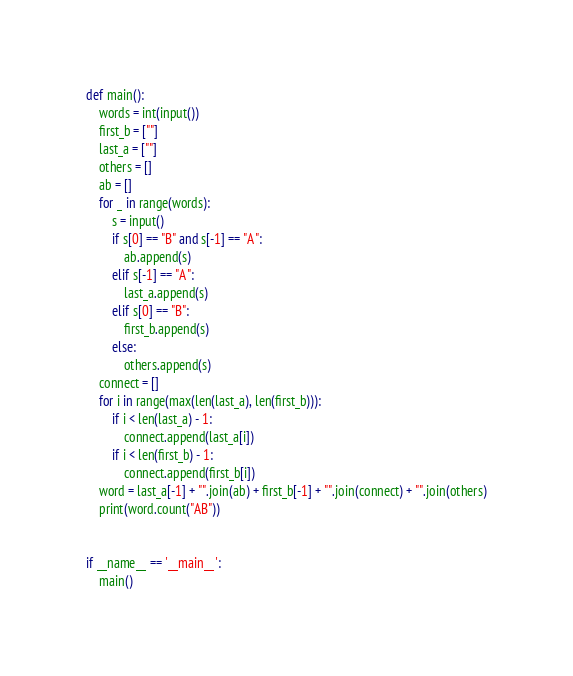<code> <loc_0><loc_0><loc_500><loc_500><_Python_>def main():
    words = int(input())
    first_b = [""]
    last_a = [""]
    others = []
    ab = []
    for _ in range(words):
        s = input()
        if s[0] == "B" and s[-1] == "A":
            ab.append(s)
        elif s[-1] == "A":
            last_a.append(s)
        elif s[0] == "B":
            first_b.append(s)
        else:
            others.append(s)
    connect = []
    for i in range(max(len(last_a), len(first_b))):
        if i < len(last_a) - 1:
            connect.append(last_a[i])
        if i < len(first_b) - 1:
            connect.append(first_b[i])
    word = last_a[-1] + "".join(ab) + first_b[-1] + "".join(connect) + "".join(others)
    print(word.count("AB"))


if __name__ == '__main__':
    main()

</code> 